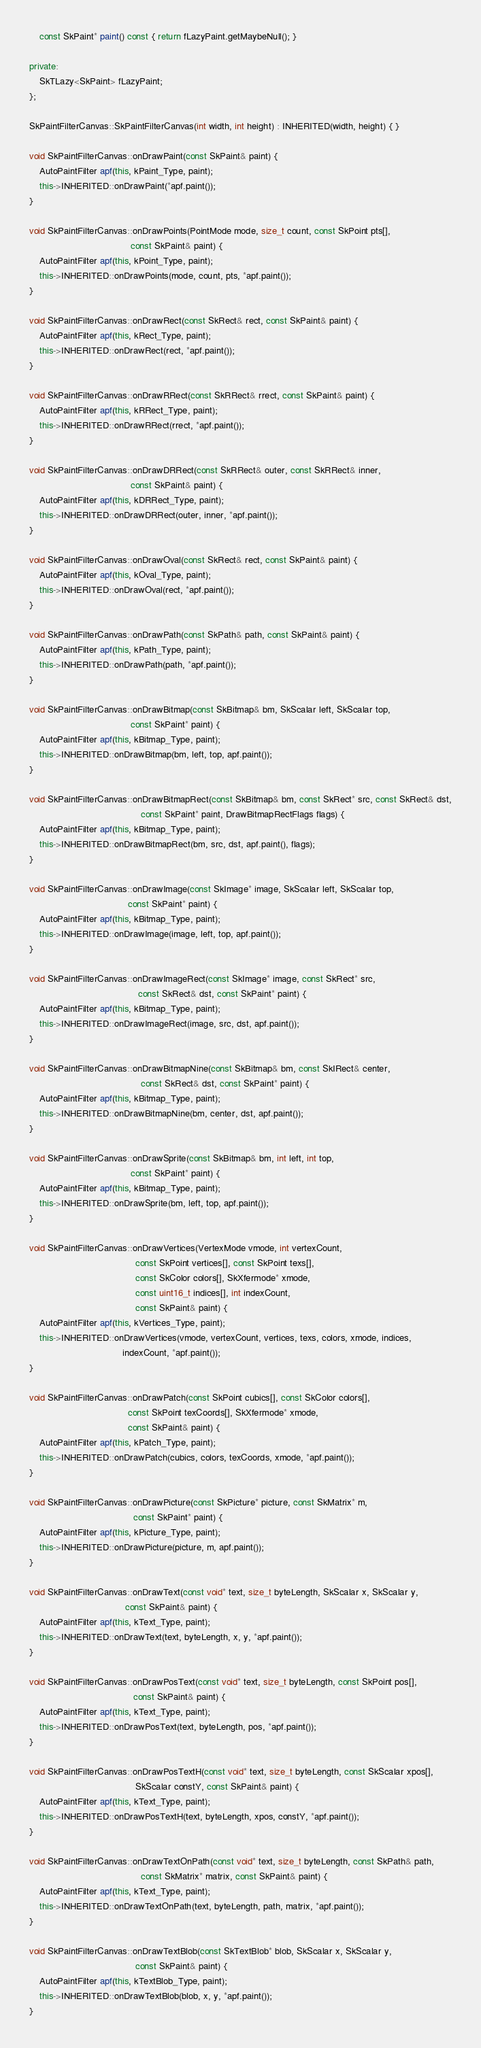Convert code to text. <code><loc_0><loc_0><loc_500><loc_500><_C++_>    const SkPaint* paint() const { return fLazyPaint.getMaybeNull(); }

private:
    SkTLazy<SkPaint> fLazyPaint;
};

SkPaintFilterCanvas::SkPaintFilterCanvas(int width, int height) : INHERITED(width, height) { }

void SkPaintFilterCanvas::onDrawPaint(const SkPaint& paint) {
    AutoPaintFilter apf(this, kPaint_Type, paint);
    this->INHERITED::onDrawPaint(*apf.paint());
}

void SkPaintFilterCanvas::onDrawPoints(PointMode mode, size_t count, const SkPoint pts[],
                                       const SkPaint& paint) {
    AutoPaintFilter apf(this, kPoint_Type, paint);
    this->INHERITED::onDrawPoints(mode, count, pts, *apf.paint());
}

void SkPaintFilterCanvas::onDrawRect(const SkRect& rect, const SkPaint& paint) {
    AutoPaintFilter apf(this, kRect_Type, paint);
    this->INHERITED::onDrawRect(rect, *apf.paint());
}

void SkPaintFilterCanvas::onDrawRRect(const SkRRect& rrect, const SkPaint& paint) {
    AutoPaintFilter apf(this, kRRect_Type, paint);
    this->INHERITED::onDrawRRect(rrect, *apf.paint());
}

void SkPaintFilterCanvas::onDrawDRRect(const SkRRect& outer, const SkRRect& inner,
                                       const SkPaint& paint) {
    AutoPaintFilter apf(this, kDRRect_Type, paint);
    this->INHERITED::onDrawDRRect(outer, inner, *apf.paint());
}

void SkPaintFilterCanvas::onDrawOval(const SkRect& rect, const SkPaint& paint) {
    AutoPaintFilter apf(this, kOval_Type, paint);
    this->INHERITED::onDrawOval(rect, *apf.paint());
}

void SkPaintFilterCanvas::onDrawPath(const SkPath& path, const SkPaint& paint) {
    AutoPaintFilter apf(this, kPath_Type, paint);
    this->INHERITED::onDrawPath(path, *apf.paint());
}

void SkPaintFilterCanvas::onDrawBitmap(const SkBitmap& bm, SkScalar left, SkScalar top,
                                       const SkPaint* paint) {
    AutoPaintFilter apf(this, kBitmap_Type, paint);
    this->INHERITED::onDrawBitmap(bm, left, top, apf.paint());
}

void SkPaintFilterCanvas::onDrawBitmapRect(const SkBitmap& bm, const SkRect* src, const SkRect& dst,
                                           const SkPaint* paint, DrawBitmapRectFlags flags) {
    AutoPaintFilter apf(this, kBitmap_Type, paint);
    this->INHERITED::onDrawBitmapRect(bm, src, dst, apf.paint(), flags);
}

void SkPaintFilterCanvas::onDrawImage(const SkImage* image, SkScalar left, SkScalar top,
                                      const SkPaint* paint) {
    AutoPaintFilter apf(this, kBitmap_Type, paint);
    this->INHERITED::onDrawImage(image, left, top, apf.paint());
}

void SkPaintFilterCanvas::onDrawImageRect(const SkImage* image, const SkRect* src,
                                          const SkRect& dst, const SkPaint* paint) {
    AutoPaintFilter apf(this, kBitmap_Type, paint);
    this->INHERITED::onDrawImageRect(image, src, dst, apf.paint());
}

void SkPaintFilterCanvas::onDrawBitmapNine(const SkBitmap& bm, const SkIRect& center,
                                           const SkRect& dst, const SkPaint* paint) {
    AutoPaintFilter apf(this, kBitmap_Type, paint);
    this->INHERITED::onDrawBitmapNine(bm, center, dst, apf.paint());
}

void SkPaintFilterCanvas::onDrawSprite(const SkBitmap& bm, int left, int top,
                                       const SkPaint* paint) {
    AutoPaintFilter apf(this, kBitmap_Type, paint);
    this->INHERITED::onDrawSprite(bm, left, top, apf.paint());
}

void SkPaintFilterCanvas::onDrawVertices(VertexMode vmode, int vertexCount,
                                         const SkPoint vertices[], const SkPoint texs[],
                                         const SkColor colors[], SkXfermode* xmode,
                                         const uint16_t indices[], int indexCount,
                                         const SkPaint& paint) {
    AutoPaintFilter apf(this, kVertices_Type, paint);
    this->INHERITED::onDrawVertices(vmode, vertexCount, vertices, texs, colors, xmode, indices,
                                    indexCount, *apf.paint());
}

void SkPaintFilterCanvas::onDrawPatch(const SkPoint cubics[], const SkColor colors[],
                                      const SkPoint texCoords[], SkXfermode* xmode,
                                      const SkPaint& paint) {
    AutoPaintFilter apf(this, kPatch_Type, paint);
    this->INHERITED::onDrawPatch(cubics, colors, texCoords, xmode, *apf.paint());
}

void SkPaintFilterCanvas::onDrawPicture(const SkPicture* picture, const SkMatrix* m,
                                        const SkPaint* paint) {
    AutoPaintFilter apf(this, kPicture_Type, paint);
    this->INHERITED::onDrawPicture(picture, m, apf.paint());
}

void SkPaintFilterCanvas::onDrawText(const void* text, size_t byteLength, SkScalar x, SkScalar y,
                                     const SkPaint& paint) {
    AutoPaintFilter apf(this, kText_Type, paint);
    this->INHERITED::onDrawText(text, byteLength, x, y, *apf.paint());
}

void SkPaintFilterCanvas::onDrawPosText(const void* text, size_t byteLength, const SkPoint pos[],
                                        const SkPaint& paint) {
    AutoPaintFilter apf(this, kText_Type, paint);
    this->INHERITED::onDrawPosText(text, byteLength, pos, *apf.paint());
}

void SkPaintFilterCanvas::onDrawPosTextH(const void* text, size_t byteLength, const SkScalar xpos[],
                                         SkScalar constY, const SkPaint& paint) {
    AutoPaintFilter apf(this, kText_Type, paint);
    this->INHERITED::onDrawPosTextH(text, byteLength, xpos, constY, *apf.paint());
}

void SkPaintFilterCanvas::onDrawTextOnPath(const void* text, size_t byteLength, const SkPath& path,
                                           const SkMatrix* matrix, const SkPaint& paint) {
    AutoPaintFilter apf(this, kText_Type, paint);
    this->INHERITED::onDrawTextOnPath(text, byteLength, path, matrix, *apf.paint());
}

void SkPaintFilterCanvas::onDrawTextBlob(const SkTextBlob* blob, SkScalar x, SkScalar y,
                                         const SkPaint& paint) {
    AutoPaintFilter apf(this, kTextBlob_Type, paint);
    this->INHERITED::onDrawTextBlob(blob, x, y, *apf.paint());
}
</code> 